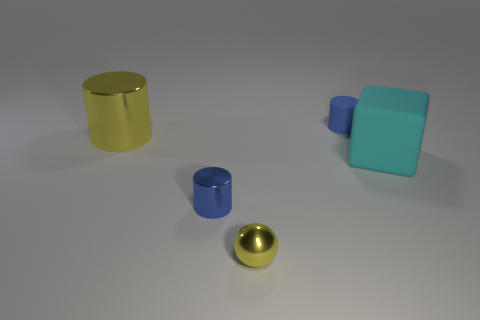There is a small object that is the same color as the large metal cylinder; what is its shape?
Your answer should be compact. Sphere. Is the color of the large thing that is in front of the yellow cylinder the same as the sphere?
Offer a very short reply. No. What number of blue shiny cylinders have the same size as the yellow sphere?
Offer a terse response. 1. What is the shape of the other small object that is the same material as the cyan thing?
Your answer should be compact. Cylinder. Is there a rubber block that has the same color as the metallic ball?
Your response must be concise. No. What is the material of the large cyan block?
Give a very brief answer. Rubber. How many things are either big brown shiny spheres or large cyan rubber things?
Your response must be concise. 1. There is a blue cylinder in front of the yellow cylinder; how big is it?
Provide a short and direct response. Small. What number of other things are there of the same material as the yellow cylinder
Offer a very short reply. 2. There is a small blue thing that is in front of the cyan rubber block; are there any rubber things to the left of it?
Make the answer very short. No. 